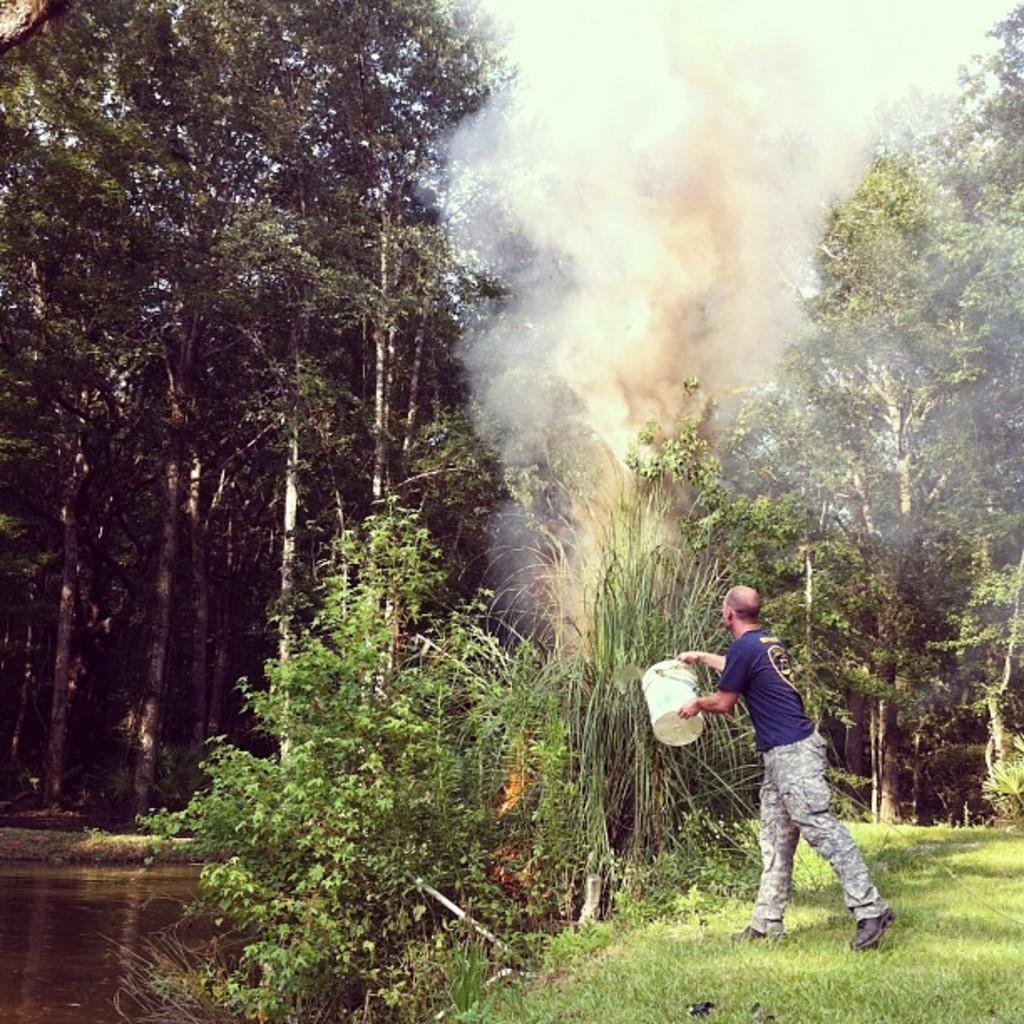Please provide a concise description of this image. In this picture there is a person standing on the grass and he is holding the bucket. At the back there are trees. At the top there is a smoke and there is sky. At the bottom there is water and grass. 